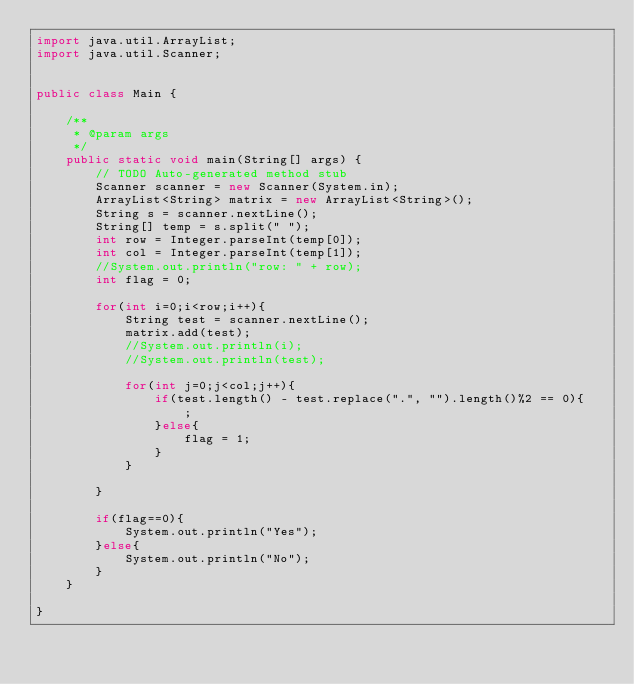Convert code to text. <code><loc_0><loc_0><loc_500><loc_500><_Java_>import java.util.ArrayList;
import java.util.Scanner;


public class Main {

	/**
	 * @param args
	 */
	public static void main(String[] args) {
		// TODO Auto-generated method stub
		Scanner scanner = new Scanner(System.in);
		ArrayList<String> matrix = new ArrayList<String>();
		String s = scanner.nextLine();
		String[] temp = s.split(" ");
		int row = Integer.parseInt(temp[0]);
		int col = Integer.parseInt(temp[1]);
		//System.out.println("row: " + row);
		int flag = 0;
		
		for(int i=0;i<row;i++){
			String test = scanner.nextLine();			
			matrix.add(test);
			//System.out.println(i);
			//System.out.println(test);
			
			for(int j=0;j<col;j++){
				if(test.length() - test.replace(".", "").length()%2 == 0){
					;
				}else{
					flag = 1;
				}
			}
			
		}
		
		if(flag==0){
			System.out.println("Yes");
		}else{
			System.out.println("No");
		}
	}

}
</code> 